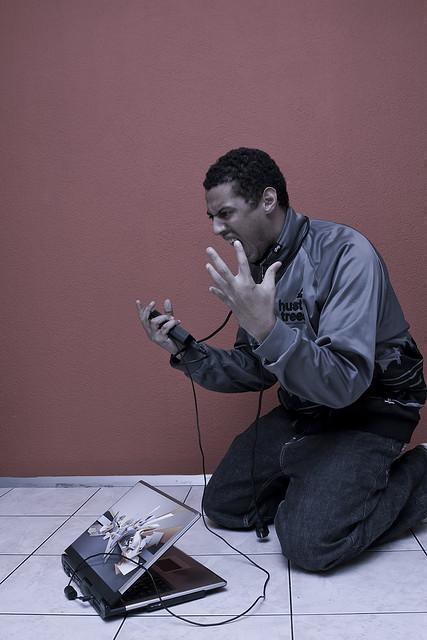How many laptops are there?
Give a very brief answer. 1. 